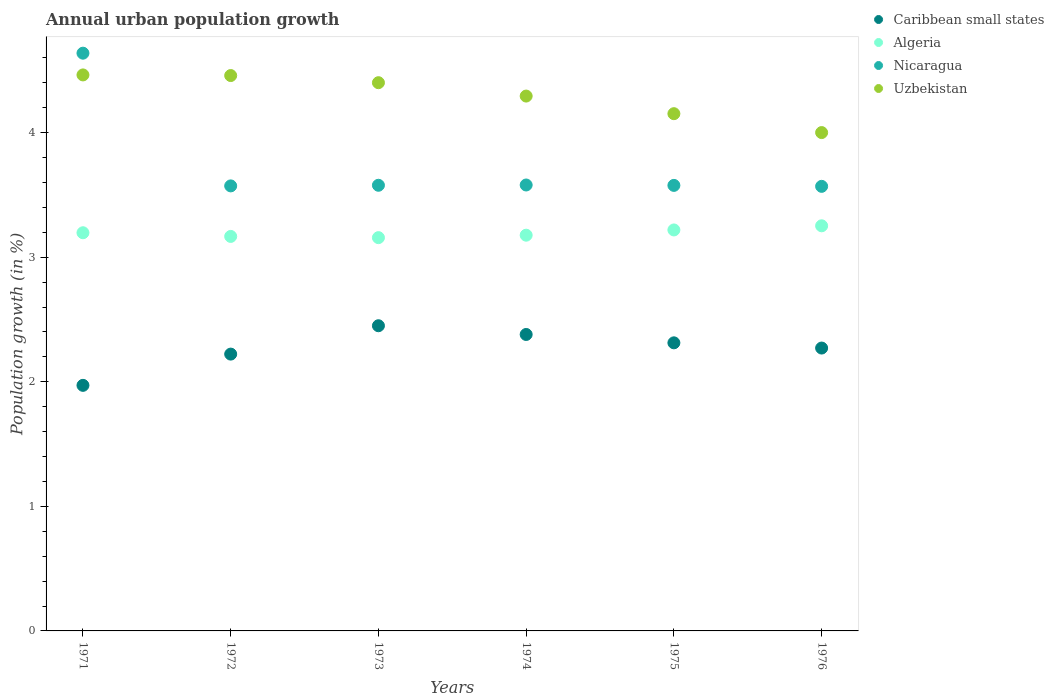How many different coloured dotlines are there?
Provide a short and direct response. 4. What is the percentage of urban population growth in Caribbean small states in 1973?
Offer a very short reply. 2.45. Across all years, what is the maximum percentage of urban population growth in Caribbean small states?
Offer a terse response. 2.45. Across all years, what is the minimum percentage of urban population growth in Caribbean small states?
Your answer should be compact. 1.97. In which year was the percentage of urban population growth in Algeria maximum?
Make the answer very short. 1976. In which year was the percentage of urban population growth in Nicaragua minimum?
Your answer should be compact. 1976. What is the total percentage of urban population growth in Nicaragua in the graph?
Your answer should be very brief. 22.51. What is the difference between the percentage of urban population growth in Nicaragua in 1973 and that in 1976?
Keep it short and to the point. 0.01. What is the difference between the percentage of urban population growth in Nicaragua in 1971 and the percentage of urban population growth in Caribbean small states in 1975?
Keep it short and to the point. 2.33. What is the average percentage of urban population growth in Caribbean small states per year?
Offer a very short reply. 2.27. In the year 1972, what is the difference between the percentage of urban population growth in Uzbekistan and percentage of urban population growth in Nicaragua?
Provide a succinct answer. 0.89. What is the ratio of the percentage of urban population growth in Nicaragua in 1972 to that in 1973?
Offer a very short reply. 1. Is the percentage of urban population growth in Nicaragua in 1972 less than that in 1975?
Give a very brief answer. Yes. Is the difference between the percentage of urban population growth in Uzbekistan in 1973 and 1975 greater than the difference between the percentage of urban population growth in Nicaragua in 1973 and 1975?
Offer a terse response. Yes. What is the difference between the highest and the second highest percentage of urban population growth in Algeria?
Your answer should be very brief. 0.03. What is the difference between the highest and the lowest percentage of urban population growth in Nicaragua?
Your answer should be compact. 1.07. Is it the case that in every year, the sum of the percentage of urban population growth in Nicaragua and percentage of urban population growth in Uzbekistan  is greater than the percentage of urban population growth in Caribbean small states?
Your answer should be compact. Yes. Does the percentage of urban population growth in Caribbean small states monotonically increase over the years?
Offer a very short reply. No. Is the percentage of urban population growth in Algeria strictly greater than the percentage of urban population growth in Uzbekistan over the years?
Your answer should be very brief. No. Is the percentage of urban population growth in Caribbean small states strictly less than the percentage of urban population growth in Nicaragua over the years?
Keep it short and to the point. Yes. How many years are there in the graph?
Offer a terse response. 6. What is the difference between two consecutive major ticks on the Y-axis?
Offer a terse response. 1. Are the values on the major ticks of Y-axis written in scientific E-notation?
Your answer should be compact. No. Does the graph contain any zero values?
Give a very brief answer. No. Does the graph contain grids?
Give a very brief answer. No. Where does the legend appear in the graph?
Your answer should be very brief. Top right. How many legend labels are there?
Keep it short and to the point. 4. What is the title of the graph?
Keep it short and to the point. Annual urban population growth. Does "Nepal" appear as one of the legend labels in the graph?
Your answer should be compact. No. What is the label or title of the X-axis?
Your answer should be very brief. Years. What is the label or title of the Y-axis?
Offer a terse response. Population growth (in %). What is the Population growth (in %) of Caribbean small states in 1971?
Offer a very short reply. 1.97. What is the Population growth (in %) in Algeria in 1971?
Your response must be concise. 3.2. What is the Population growth (in %) in Nicaragua in 1971?
Offer a terse response. 4.64. What is the Population growth (in %) of Uzbekistan in 1971?
Offer a very short reply. 4.46. What is the Population growth (in %) of Caribbean small states in 1972?
Offer a terse response. 2.22. What is the Population growth (in %) of Algeria in 1972?
Your response must be concise. 3.17. What is the Population growth (in %) in Nicaragua in 1972?
Provide a short and direct response. 3.57. What is the Population growth (in %) in Uzbekistan in 1972?
Your response must be concise. 4.46. What is the Population growth (in %) in Caribbean small states in 1973?
Your response must be concise. 2.45. What is the Population growth (in %) in Algeria in 1973?
Give a very brief answer. 3.16. What is the Population growth (in %) in Nicaragua in 1973?
Provide a short and direct response. 3.58. What is the Population growth (in %) in Uzbekistan in 1973?
Provide a succinct answer. 4.4. What is the Population growth (in %) in Caribbean small states in 1974?
Ensure brevity in your answer.  2.38. What is the Population growth (in %) in Algeria in 1974?
Your answer should be compact. 3.18. What is the Population growth (in %) of Nicaragua in 1974?
Ensure brevity in your answer.  3.58. What is the Population growth (in %) of Uzbekistan in 1974?
Provide a short and direct response. 4.29. What is the Population growth (in %) of Caribbean small states in 1975?
Give a very brief answer. 2.31. What is the Population growth (in %) of Algeria in 1975?
Your answer should be compact. 3.22. What is the Population growth (in %) of Nicaragua in 1975?
Give a very brief answer. 3.58. What is the Population growth (in %) in Uzbekistan in 1975?
Provide a short and direct response. 4.15. What is the Population growth (in %) of Caribbean small states in 1976?
Keep it short and to the point. 2.27. What is the Population growth (in %) in Algeria in 1976?
Ensure brevity in your answer.  3.25. What is the Population growth (in %) of Nicaragua in 1976?
Give a very brief answer. 3.57. What is the Population growth (in %) of Uzbekistan in 1976?
Give a very brief answer. 4. Across all years, what is the maximum Population growth (in %) in Caribbean small states?
Your answer should be compact. 2.45. Across all years, what is the maximum Population growth (in %) in Algeria?
Keep it short and to the point. 3.25. Across all years, what is the maximum Population growth (in %) of Nicaragua?
Ensure brevity in your answer.  4.64. Across all years, what is the maximum Population growth (in %) of Uzbekistan?
Ensure brevity in your answer.  4.46. Across all years, what is the minimum Population growth (in %) of Caribbean small states?
Provide a short and direct response. 1.97. Across all years, what is the minimum Population growth (in %) in Algeria?
Give a very brief answer. 3.16. Across all years, what is the minimum Population growth (in %) in Nicaragua?
Offer a terse response. 3.57. Across all years, what is the minimum Population growth (in %) of Uzbekistan?
Provide a short and direct response. 4. What is the total Population growth (in %) in Caribbean small states in the graph?
Offer a very short reply. 13.61. What is the total Population growth (in %) in Algeria in the graph?
Your answer should be very brief. 19.17. What is the total Population growth (in %) of Nicaragua in the graph?
Offer a very short reply. 22.51. What is the total Population growth (in %) in Uzbekistan in the graph?
Give a very brief answer. 25.77. What is the difference between the Population growth (in %) of Caribbean small states in 1971 and that in 1972?
Your answer should be compact. -0.25. What is the difference between the Population growth (in %) of Algeria in 1971 and that in 1972?
Provide a succinct answer. 0.03. What is the difference between the Population growth (in %) of Nicaragua in 1971 and that in 1972?
Your response must be concise. 1.07. What is the difference between the Population growth (in %) in Uzbekistan in 1971 and that in 1972?
Your answer should be very brief. 0.01. What is the difference between the Population growth (in %) of Caribbean small states in 1971 and that in 1973?
Ensure brevity in your answer.  -0.48. What is the difference between the Population growth (in %) in Algeria in 1971 and that in 1973?
Ensure brevity in your answer.  0.04. What is the difference between the Population growth (in %) of Nicaragua in 1971 and that in 1973?
Provide a succinct answer. 1.06. What is the difference between the Population growth (in %) in Uzbekistan in 1971 and that in 1973?
Offer a very short reply. 0.06. What is the difference between the Population growth (in %) in Caribbean small states in 1971 and that in 1974?
Offer a terse response. -0.41. What is the difference between the Population growth (in %) in Algeria in 1971 and that in 1974?
Make the answer very short. 0.02. What is the difference between the Population growth (in %) of Nicaragua in 1971 and that in 1974?
Keep it short and to the point. 1.06. What is the difference between the Population growth (in %) of Uzbekistan in 1971 and that in 1974?
Your answer should be compact. 0.17. What is the difference between the Population growth (in %) of Caribbean small states in 1971 and that in 1975?
Your answer should be very brief. -0.34. What is the difference between the Population growth (in %) of Algeria in 1971 and that in 1975?
Offer a terse response. -0.02. What is the difference between the Population growth (in %) of Nicaragua in 1971 and that in 1975?
Your answer should be compact. 1.06. What is the difference between the Population growth (in %) of Uzbekistan in 1971 and that in 1975?
Your answer should be compact. 0.31. What is the difference between the Population growth (in %) of Caribbean small states in 1971 and that in 1976?
Your response must be concise. -0.3. What is the difference between the Population growth (in %) of Algeria in 1971 and that in 1976?
Make the answer very short. -0.06. What is the difference between the Population growth (in %) of Nicaragua in 1971 and that in 1976?
Your answer should be compact. 1.07. What is the difference between the Population growth (in %) of Uzbekistan in 1971 and that in 1976?
Give a very brief answer. 0.46. What is the difference between the Population growth (in %) in Caribbean small states in 1972 and that in 1973?
Make the answer very short. -0.23. What is the difference between the Population growth (in %) in Algeria in 1972 and that in 1973?
Ensure brevity in your answer.  0.01. What is the difference between the Population growth (in %) of Nicaragua in 1972 and that in 1973?
Make the answer very short. -0.01. What is the difference between the Population growth (in %) of Uzbekistan in 1972 and that in 1973?
Provide a succinct answer. 0.06. What is the difference between the Population growth (in %) in Caribbean small states in 1972 and that in 1974?
Your answer should be compact. -0.16. What is the difference between the Population growth (in %) of Algeria in 1972 and that in 1974?
Your response must be concise. -0.01. What is the difference between the Population growth (in %) in Nicaragua in 1972 and that in 1974?
Offer a very short reply. -0.01. What is the difference between the Population growth (in %) of Uzbekistan in 1972 and that in 1974?
Provide a succinct answer. 0.16. What is the difference between the Population growth (in %) in Caribbean small states in 1972 and that in 1975?
Your answer should be compact. -0.09. What is the difference between the Population growth (in %) of Algeria in 1972 and that in 1975?
Make the answer very short. -0.05. What is the difference between the Population growth (in %) of Nicaragua in 1972 and that in 1975?
Your answer should be very brief. -0. What is the difference between the Population growth (in %) of Uzbekistan in 1972 and that in 1975?
Provide a short and direct response. 0.31. What is the difference between the Population growth (in %) in Caribbean small states in 1972 and that in 1976?
Give a very brief answer. -0.05. What is the difference between the Population growth (in %) in Algeria in 1972 and that in 1976?
Your answer should be compact. -0.09. What is the difference between the Population growth (in %) of Nicaragua in 1972 and that in 1976?
Keep it short and to the point. 0. What is the difference between the Population growth (in %) of Uzbekistan in 1972 and that in 1976?
Offer a very short reply. 0.46. What is the difference between the Population growth (in %) in Caribbean small states in 1973 and that in 1974?
Give a very brief answer. 0.07. What is the difference between the Population growth (in %) of Algeria in 1973 and that in 1974?
Provide a short and direct response. -0.02. What is the difference between the Population growth (in %) in Nicaragua in 1973 and that in 1974?
Ensure brevity in your answer.  -0. What is the difference between the Population growth (in %) in Uzbekistan in 1973 and that in 1974?
Your answer should be very brief. 0.11. What is the difference between the Population growth (in %) of Caribbean small states in 1973 and that in 1975?
Keep it short and to the point. 0.14. What is the difference between the Population growth (in %) in Algeria in 1973 and that in 1975?
Make the answer very short. -0.06. What is the difference between the Population growth (in %) of Uzbekistan in 1973 and that in 1975?
Ensure brevity in your answer.  0.25. What is the difference between the Population growth (in %) in Caribbean small states in 1973 and that in 1976?
Your answer should be very brief. 0.18. What is the difference between the Population growth (in %) in Algeria in 1973 and that in 1976?
Provide a short and direct response. -0.1. What is the difference between the Population growth (in %) of Nicaragua in 1973 and that in 1976?
Provide a succinct answer. 0.01. What is the difference between the Population growth (in %) in Uzbekistan in 1973 and that in 1976?
Ensure brevity in your answer.  0.4. What is the difference between the Population growth (in %) of Caribbean small states in 1974 and that in 1975?
Offer a terse response. 0.07. What is the difference between the Population growth (in %) in Algeria in 1974 and that in 1975?
Ensure brevity in your answer.  -0.04. What is the difference between the Population growth (in %) of Nicaragua in 1974 and that in 1975?
Your answer should be compact. 0. What is the difference between the Population growth (in %) in Uzbekistan in 1974 and that in 1975?
Make the answer very short. 0.14. What is the difference between the Population growth (in %) of Caribbean small states in 1974 and that in 1976?
Your response must be concise. 0.11. What is the difference between the Population growth (in %) of Algeria in 1974 and that in 1976?
Give a very brief answer. -0.08. What is the difference between the Population growth (in %) of Nicaragua in 1974 and that in 1976?
Your answer should be very brief. 0.01. What is the difference between the Population growth (in %) of Uzbekistan in 1974 and that in 1976?
Your answer should be compact. 0.29. What is the difference between the Population growth (in %) of Caribbean small states in 1975 and that in 1976?
Offer a very short reply. 0.04. What is the difference between the Population growth (in %) in Algeria in 1975 and that in 1976?
Ensure brevity in your answer.  -0.03. What is the difference between the Population growth (in %) of Nicaragua in 1975 and that in 1976?
Keep it short and to the point. 0.01. What is the difference between the Population growth (in %) of Uzbekistan in 1975 and that in 1976?
Keep it short and to the point. 0.15. What is the difference between the Population growth (in %) of Caribbean small states in 1971 and the Population growth (in %) of Algeria in 1972?
Provide a short and direct response. -1.2. What is the difference between the Population growth (in %) of Caribbean small states in 1971 and the Population growth (in %) of Nicaragua in 1972?
Make the answer very short. -1.6. What is the difference between the Population growth (in %) in Caribbean small states in 1971 and the Population growth (in %) in Uzbekistan in 1972?
Your answer should be compact. -2.49. What is the difference between the Population growth (in %) of Algeria in 1971 and the Population growth (in %) of Nicaragua in 1972?
Your answer should be very brief. -0.38. What is the difference between the Population growth (in %) of Algeria in 1971 and the Population growth (in %) of Uzbekistan in 1972?
Your answer should be very brief. -1.26. What is the difference between the Population growth (in %) in Nicaragua in 1971 and the Population growth (in %) in Uzbekistan in 1972?
Make the answer very short. 0.18. What is the difference between the Population growth (in %) of Caribbean small states in 1971 and the Population growth (in %) of Algeria in 1973?
Provide a succinct answer. -1.19. What is the difference between the Population growth (in %) in Caribbean small states in 1971 and the Population growth (in %) in Nicaragua in 1973?
Your answer should be very brief. -1.61. What is the difference between the Population growth (in %) in Caribbean small states in 1971 and the Population growth (in %) in Uzbekistan in 1973?
Keep it short and to the point. -2.43. What is the difference between the Population growth (in %) of Algeria in 1971 and the Population growth (in %) of Nicaragua in 1973?
Ensure brevity in your answer.  -0.38. What is the difference between the Population growth (in %) of Algeria in 1971 and the Population growth (in %) of Uzbekistan in 1973?
Give a very brief answer. -1.2. What is the difference between the Population growth (in %) in Nicaragua in 1971 and the Population growth (in %) in Uzbekistan in 1973?
Make the answer very short. 0.24. What is the difference between the Population growth (in %) of Caribbean small states in 1971 and the Population growth (in %) of Algeria in 1974?
Your answer should be compact. -1.21. What is the difference between the Population growth (in %) in Caribbean small states in 1971 and the Population growth (in %) in Nicaragua in 1974?
Your answer should be compact. -1.61. What is the difference between the Population growth (in %) in Caribbean small states in 1971 and the Population growth (in %) in Uzbekistan in 1974?
Provide a succinct answer. -2.32. What is the difference between the Population growth (in %) in Algeria in 1971 and the Population growth (in %) in Nicaragua in 1974?
Make the answer very short. -0.38. What is the difference between the Population growth (in %) in Algeria in 1971 and the Population growth (in %) in Uzbekistan in 1974?
Make the answer very short. -1.1. What is the difference between the Population growth (in %) of Nicaragua in 1971 and the Population growth (in %) of Uzbekistan in 1974?
Offer a very short reply. 0.34. What is the difference between the Population growth (in %) in Caribbean small states in 1971 and the Population growth (in %) in Algeria in 1975?
Make the answer very short. -1.25. What is the difference between the Population growth (in %) of Caribbean small states in 1971 and the Population growth (in %) of Nicaragua in 1975?
Give a very brief answer. -1.61. What is the difference between the Population growth (in %) in Caribbean small states in 1971 and the Population growth (in %) in Uzbekistan in 1975?
Your response must be concise. -2.18. What is the difference between the Population growth (in %) of Algeria in 1971 and the Population growth (in %) of Nicaragua in 1975?
Your response must be concise. -0.38. What is the difference between the Population growth (in %) of Algeria in 1971 and the Population growth (in %) of Uzbekistan in 1975?
Offer a very short reply. -0.96. What is the difference between the Population growth (in %) in Nicaragua in 1971 and the Population growth (in %) in Uzbekistan in 1975?
Your answer should be compact. 0.49. What is the difference between the Population growth (in %) in Caribbean small states in 1971 and the Population growth (in %) in Algeria in 1976?
Provide a short and direct response. -1.28. What is the difference between the Population growth (in %) in Caribbean small states in 1971 and the Population growth (in %) in Nicaragua in 1976?
Provide a short and direct response. -1.6. What is the difference between the Population growth (in %) of Caribbean small states in 1971 and the Population growth (in %) of Uzbekistan in 1976?
Ensure brevity in your answer.  -2.03. What is the difference between the Population growth (in %) of Algeria in 1971 and the Population growth (in %) of Nicaragua in 1976?
Offer a terse response. -0.37. What is the difference between the Population growth (in %) of Algeria in 1971 and the Population growth (in %) of Uzbekistan in 1976?
Make the answer very short. -0.8. What is the difference between the Population growth (in %) in Nicaragua in 1971 and the Population growth (in %) in Uzbekistan in 1976?
Make the answer very short. 0.64. What is the difference between the Population growth (in %) in Caribbean small states in 1972 and the Population growth (in %) in Algeria in 1973?
Offer a terse response. -0.93. What is the difference between the Population growth (in %) in Caribbean small states in 1972 and the Population growth (in %) in Nicaragua in 1973?
Your answer should be very brief. -1.36. What is the difference between the Population growth (in %) of Caribbean small states in 1972 and the Population growth (in %) of Uzbekistan in 1973?
Provide a short and direct response. -2.18. What is the difference between the Population growth (in %) in Algeria in 1972 and the Population growth (in %) in Nicaragua in 1973?
Offer a terse response. -0.41. What is the difference between the Population growth (in %) in Algeria in 1972 and the Population growth (in %) in Uzbekistan in 1973?
Provide a short and direct response. -1.23. What is the difference between the Population growth (in %) of Nicaragua in 1972 and the Population growth (in %) of Uzbekistan in 1973?
Your answer should be very brief. -0.83. What is the difference between the Population growth (in %) of Caribbean small states in 1972 and the Population growth (in %) of Algeria in 1974?
Give a very brief answer. -0.95. What is the difference between the Population growth (in %) of Caribbean small states in 1972 and the Population growth (in %) of Nicaragua in 1974?
Provide a succinct answer. -1.36. What is the difference between the Population growth (in %) in Caribbean small states in 1972 and the Population growth (in %) in Uzbekistan in 1974?
Ensure brevity in your answer.  -2.07. What is the difference between the Population growth (in %) in Algeria in 1972 and the Population growth (in %) in Nicaragua in 1974?
Provide a short and direct response. -0.41. What is the difference between the Population growth (in %) in Algeria in 1972 and the Population growth (in %) in Uzbekistan in 1974?
Keep it short and to the point. -1.13. What is the difference between the Population growth (in %) of Nicaragua in 1972 and the Population growth (in %) of Uzbekistan in 1974?
Provide a succinct answer. -0.72. What is the difference between the Population growth (in %) in Caribbean small states in 1972 and the Population growth (in %) in Algeria in 1975?
Provide a short and direct response. -1. What is the difference between the Population growth (in %) in Caribbean small states in 1972 and the Population growth (in %) in Nicaragua in 1975?
Provide a short and direct response. -1.35. What is the difference between the Population growth (in %) in Caribbean small states in 1972 and the Population growth (in %) in Uzbekistan in 1975?
Provide a succinct answer. -1.93. What is the difference between the Population growth (in %) in Algeria in 1972 and the Population growth (in %) in Nicaragua in 1975?
Offer a very short reply. -0.41. What is the difference between the Population growth (in %) in Algeria in 1972 and the Population growth (in %) in Uzbekistan in 1975?
Give a very brief answer. -0.99. What is the difference between the Population growth (in %) of Nicaragua in 1972 and the Population growth (in %) of Uzbekistan in 1975?
Provide a succinct answer. -0.58. What is the difference between the Population growth (in %) of Caribbean small states in 1972 and the Population growth (in %) of Algeria in 1976?
Offer a terse response. -1.03. What is the difference between the Population growth (in %) of Caribbean small states in 1972 and the Population growth (in %) of Nicaragua in 1976?
Your answer should be very brief. -1.35. What is the difference between the Population growth (in %) of Caribbean small states in 1972 and the Population growth (in %) of Uzbekistan in 1976?
Your answer should be compact. -1.78. What is the difference between the Population growth (in %) in Algeria in 1972 and the Population growth (in %) in Nicaragua in 1976?
Your answer should be compact. -0.4. What is the difference between the Population growth (in %) of Algeria in 1972 and the Population growth (in %) of Uzbekistan in 1976?
Provide a succinct answer. -0.83. What is the difference between the Population growth (in %) in Nicaragua in 1972 and the Population growth (in %) in Uzbekistan in 1976?
Your response must be concise. -0.43. What is the difference between the Population growth (in %) in Caribbean small states in 1973 and the Population growth (in %) in Algeria in 1974?
Your answer should be compact. -0.73. What is the difference between the Population growth (in %) in Caribbean small states in 1973 and the Population growth (in %) in Nicaragua in 1974?
Offer a very short reply. -1.13. What is the difference between the Population growth (in %) in Caribbean small states in 1973 and the Population growth (in %) in Uzbekistan in 1974?
Offer a very short reply. -1.84. What is the difference between the Population growth (in %) in Algeria in 1973 and the Population growth (in %) in Nicaragua in 1974?
Give a very brief answer. -0.42. What is the difference between the Population growth (in %) of Algeria in 1973 and the Population growth (in %) of Uzbekistan in 1974?
Ensure brevity in your answer.  -1.14. What is the difference between the Population growth (in %) in Nicaragua in 1973 and the Population growth (in %) in Uzbekistan in 1974?
Offer a terse response. -0.72. What is the difference between the Population growth (in %) of Caribbean small states in 1973 and the Population growth (in %) of Algeria in 1975?
Make the answer very short. -0.77. What is the difference between the Population growth (in %) in Caribbean small states in 1973 and the Population growth (in %) in Nicaragua in 1975?
Provide a short and direct response. -1.13. What is the difference between the Population growth (in %) in Caribbean small states in 1973 and the Population growth (in %) in Uzbekistan in 1975?
Offer a terse response. -1.7. What is the difference between the Population growth (in %) in Algeria in 1973 and the Population growth (in %) in Nicaragua in 1975?
Provide a short and direct response. -0.42. What is the difference between the Population growth (in %) in Algeria in 1973 and the Population growth (in %) in Uzbekistan in 1975?
Your answer should be compact. -1. What is the difference between the Population growth (in %) in Nicaragua in 1973 and the Population growth (in %) in Uzbekistan in 1975?
Offer a very short reply. -0.57. What is the difference between the Population growth (in %) in Caribbean small states in 1973 and the Population growth (in %) in Algeria in 1976?
Your response must be concise. -0.8. What is the difference between the Population growth (in %) of Caribbean small states in 1973 and the Population growth (in %) of Nicaragua in 1976?
Ensure brevity in your answer.  -1.12. What is the difference between the Population growth (in %) in Caribbean small states in 1973 and the Population growth (in %) in Uzbekistan in 1976?
Make the answer very short. -1.55. What is the difference between the Population growth (in %) in Algeria in 1973 and the Population growth (in %) in Nicaragua in 1976?
Make the answer very short. -0.41. What is the difference between the Population growth (in %) in Algeria in 1973 and the Population growth (in %) in Uzbekistan in 1976?
Make the answer very short. -0.84. What is the difference between the Population growth (in %) in Nicaragua in 1973 and the Population growth (in %) in Uzbekistan in 1976?
Provide a short and direct response. -0.42. What is the difference between the Population growth (in %) in Caribbean small states in 1974 and the Population growth (in %) in Algeria in 1975?
Offer a very short reply. -0.84. What is the difference between the Population growth (in %) of Caribbean small states in 1974 and the Population growth (in %) of Nicaragua in 1975?
Provide a succinct answer. -1.2. What is the difference between the Population growth (in %) of Caribbean small states in 1974 and the Population growth (in %) of Uzbekistan in 1975?
Give a very brief answer. -1.77. What is the difference between the Population growth (in %) in Algeria in 1974 and the Population growth (in %) in Nicaragua in 1975?
Offer a terse response. -0.4. What is the difference between the Population growth (in %) of Algeria in 1974 and the Population growth (in %) of Uzbekistan in 1975?
Ensure brevity in your answer.  -0.98. What is the difference between the Population growth (in %) of Nicaragua in 1974 and the Population growth (in %) of Uzbekistan in 1975?
Offer a very short reply. -0.57. What is the difference between the Population growth (in %) in Caribbean small states in 1974 and the Population growth (in %) in Algeria in 1976?
Offer a terse response. -0.87. What is the difference between the Population growth (in %) in Caribbean small states in 1974 and the Population growth (in %) in Nicaragua in 1976?
Your answer should be compact. -1.19. What is the difference between the Population growth (in %) of Caribbean small states in 1974 and the Population growth (in %) of Uzbekistan in 1976?
Your response must be concise. -1.62. What is the difference between the Population growth (in %) in Algeria in 1974 and the Population growth (in %) in Nicaragua in 1976?
Give a very brief answer. -0.39. What is the difference between the Population growth (in %) in Algeria in 1974 and the Population growth (in %) in Uzbekistan in 1976?
Give a very brief answer. -0.82. What is the difference between the Population growth (in %) of Nicaragua in 1974 and the Population growth (in %) of Uzbekistan in 1976?
Your response must be concise. -0.42. What is the difference between the Population growth (in %) of Caribbean small states in 1975 and the Population growth (in %) of Algeria in 1976?
Provide a short and direct response. -0.94. What is the difference between the Population growth (in %) of Caribbean small states in 1975 and the Population growth (in %) of Nicaragua in 1976?
Make the answer very short. -1.26. What is the difference between the Population growth (in %) in Caribbean small states in 1975 and the Population growth (in %) in Uzbekistan in 1976?
Give a very brief answer. -1.69. What is the difference between the Population growth (in %) in Algeria in 1975 and the Population growth (in %) in Nicaragua in 1976?
Keep it short and to the point. -0.35. What is the difference between the Population growth (in %) in Algeria in 1975 and the Population growth (in %) in Uzbekistan in 1976?
Your answer should be compact. -0.78. What is the difference between the Population growth (in %) of Nicaragua in 1975 and the Population growth (in %) of Uzbekistan in 1976?
Provide a short and direct response. -0.42. What is the average Population growth (in %) in Caribbean small states per year?
Give a very brief answer. 2.27. What is the average Population growth (in %) of Algeria per year?
Provide a succinct answer. 3.19. What is the average Population growth (in %) in Nicaragua per year?
Offer a very short reply. 3.75. What is the average Population growth (in %) in Uzbekistan per year?
Give a very brief answer. 4.29. In the year 1971, what is the difference between the Population growth (in %) of Caribbean small states and Population growth (in %) of Algeria?
Provide a succinct answer. -1.23. In the year 1971, what is the difference between the Population growth (in %) in Caribbean small states and Population growth (in %) in Nicaragua?
Your answer should be very brief. -2.67. In the year 1971, what is the difference between the Population growth (in %) in Caribbean small states and Population growth (in %) in Uzbekistan?
Offer a very short reply. -2.49. In the year 1971, what is the difference between the Population growth (in %) in Algeria and Population growth (in %) in Nicaragua?
Offer a terse response. -1.44. In the year 1971, what is the difference between the Population growth (in %) of Algeria and Population growth (in %) of Uzbekistan?
Your answer should be compact. -1.27. In the year 1971, what is the difference between the Population growth (in %) in Nicaragua and Population growth (in %) in Uzbekistan?
Your answer should be very brief. 0.17. In the year 1972, what is the difference between the Population growth (in %) of Caribbean small states and Population growth (in %) of Algeria?
Ensure brevity in your answer.  -0.94. In the year 1972, what is the difference between the Population growth (in %) in Caribbean small states and Population growth (in %) in Nicaragua?
Offer a terse response. -1.35. In the year 1972, what is the difference between the Population growth (in %) of Caribbean small states and Population growth (in %) of Uzbekistan?
Offer a very short reply. -2.24. In the year 1972, what is the difference between the Population growth (in %) of Algeria and Population growth (in %) of Nicaragua?
Offer a very short reply. -0.41. In the year 1972, what is the difference between the Population growth (in %) of Algeria and Population growth (in %) of Uzbekistan?
Give a very brief answer. -1.29. In the year 1972, what is the difference between the Population growth (in %) of Nicaragua and Population growth (in %) of Uzbekistan?
Offer a terse response. -0.89. In the year 1973, what is the difference between the Population growth (in %) in Caribbean small states and Population growth (in %) in Algeria?
Offer a terse response. -0.71. In the year 1973, what is the difference between the Population growth (in %) in Caribbean small states and Population growth (in %) in Nicaragua?
Your response must be concise. -1.13. In the year 1973, what is the difference between the Population growth (in %) in Caribbean small states and Population growth (in %) in Uzbekistan?
Make the answer very short. -1.95. In the year 1973, what is the difference between the Population growth (in %) in Algeria and Population growth (in %) in Nicaragua?
Ensure brevity in your answer.  -0.42. In the year 1973, what is the difference between the Population growth (in %) in Algeria and Population growth (in %) in Uzbekistan?
Provide a short and direct response. -1.24. In the year 1973, what is the difference between the Population growth (in %) in Nicaragua and Population growth (in %) in Uzbekistan?
Provide a short and direct response. -0.82. In the year 1974, what is the difference between the Population growth (in %) of Caribbean small states and Population growth (in %) of Algeria?
Offer a terse response. -0.8. In the year 1974, what is the difference between the Population growth (in %) in Caribbean small states and Population growth (in %) in Nicaragua?
Give a very brief answer. -1.2. In the year 1974, what is the difference between the Population growth (in %) in Caribbean small states and Population growth (in %) in Uzbekistan?
Your answer should be compact. -1.91. In the year 1974, what is the difference between the Population growth (in %) of Algeria and Population growth (in %) of Nicaragua?
Offer a very short reply. -0.4. In the year 1974, what is the difference between the Population growth (in %) of Algeria and Population growth (in %) of Uzbekistan?
Your answer should be very brief. -1.12. In the year 1974, what is the difference between the Population growth (in %) of Nicaragua and Population growth (in %) of Uzbekistan?
Your answer should be compact. -0.71. In the year 1975, what is the difference between the Population growth (in %) in Caribbean small states and Population growth (in %) in Algeria?
Keep it short and to the point. -0.91. In the year 1975, what is the difference between the Population growth (in %) in Caribbean small states and Population growth (in %) in Nicaragua?
Your response must be concise. -1.26. In the year 1975, what is the difference between the Population growth (in %) in Caribbean small states and Population growth (in %) in Uzbekistan?
Offer a terse response. -1.84. In the year 1975, what is the difference between the Population growth (in %) in Algeria and Population growth (in %) in Nicaragua?
Give a very brief answer. -0.36. In the year 1975, what is the difference between the Population growth (in %) of Algeria and Population growth (in %) of Uzbekistan?
Provide a succinct answer. -0.93. In the year 1975, what is the difference between the Population growth (in %) of Nicaragua and Population growth (in %) of Uzbekistan?
Give a very brief answer. -0.58. In the year 1976, what is the difference between the Population growth (in %) of Caribbean small states and Population growth (in %) of Algeria?
Give a very brief answer. -0.98. In the year 1976, what is the difference between the Population growth (in %) of Caribbean small states and Population growth (in %) of Nicaragua?
Offer a very short reply. -1.3. In the year 1976, what is the difference between the Population growth (in %) in Caribbean small states and Population growth (in %) in Uzbekistan?
Your answer should be compact. -1.73. In the year 1976, what is the difference between the Population growth (in %) of Algeria and Population growth (in %) of Nicaragua?
Keep it short and to the point. -0.32. In the year 1976, what is the difference between the Population growth (in %) in Algeria and Population growth (in %) in Uzbekistan?
Offer a terse response. -0.75. In the year 1976, what is the difference between the Population growth (in %) in Nicaragua and Population growth (in %) in Uzbekistan?
Provide a short and direct response. -0.43. What is the ratio of the Population growth (in %) in Caribbean small states in 1971 to that in 1972?
Provide a short and direct response. 0.89. What is the ratio of the Population growth (in %) in Algeria in 1971 to that in 1972?
Provide a short and direct response. 1.01. What is the ratio of the Population growth (in %) in Nicaragua in 1971 to that in 1972?
Offer a terse response. 1.3. What is the ratio of the Population growth (in %) in Caribbean small states in 1971 to that in 1973?
Your answer should be very brief. 0.8. What is the ratio of the Population growth (in %) of Algeria in 1971 to that in 1973?
Make the answer very short. 1.01. What is the ratio of the Population growth (in %) in Nicaragua in 1971 to that in 1973?
Provide a short and direct response. 1.3. What is the ratio of the Population growth (in %) of Uzbekistan in 1971 to that in 1973?
Your answer should be compact. 1.01. What is the ratio of the Population growth (in %) of Caribbean small states in 1971 to that in 1974?
Provide a succinct answer. 0.83. What is the ratio of the Population growth (in %) of Algeria in 1971 to that in 1974?
Offer a very short reply. 1.01. What is the ratio of the Population growth (in %) of Nicaragua in 1971 to that in 1974?
Your answer should be very brief. 1.3. What is the ratio of the Population growth (in %) in Uzbekistan in 1971 to that in 1974?
Keep it short and to the point. 1.04. What is the ratio of the Population growth (in %) in Caribbean small states in 1971 to that in 1975?
Your answer should be compact. 0.85. What is the ratio of the Population growth (in %) of Nicaragua in 1971 to that in 1975?
Keep it short and to the point. 1.3. What is the ratio of the Population growth (in %) in Uzbekistan in 1971 to that in 1975?
Ensure brevity in your answer.  1.07. What is the ratio of the Population growth (in %) of Caribbean small states in 1971 to that in 1976?
Provide a short and direct response. 0.87. What is the ratio of the Population growth (in %) in Algeria in 1971 to that in 1976?
Offer a terse response. 0.98. What is the ratio of the Population growth (in %) of Nicaragua in 1971 to that in 1976?
Provide a short and direct response. 1.3. What is the ratio of the Population growth (in %) in Uzbekistan in 1971 to that in 1976?
Give a very brief answer. 1.12. What is the ratio of the Population growth (in %) in Caribbean small states in 1972 to that in 1973?
Your answer should be compact. 0.91. What is the ratio of the Population growth (in %) of Algeria in 1972 to that in 1973?
Offer a terse response. 1. What is the ratio of the Population growth (in %) of Nicaragua in 1972 to that in 1973?
Provide a short and direct response. 1. What is the ratio of the Population growth (in %) of Uzbekistan in 1972 to that in 1973?
Your answer should be very brief. 1.01. What is the ratio of the Population growth (in %) in Caribbean small states in 1972 to that in 1974?
Offer a terse response. 0.93. What is the ratio of the Population growth (in %) of Algeria in 1972 to that in 1974?
Provide a succinct answer. 1. What is the ratio of the Population growth (in %) in Nicaragua in 1972 to that in 1974?
Keep it short and to the point. 1. What is the ratio of the Population growth (in %) in Uzbekistan in 1972 to that in 1974?
Your response must be concise. 1.04. What is the ratio of the Population growth (in %) in Caribbean small states in 1972 to that in 1975?
Offer a terse response. 0.96. What is the ratio of the Population growth (in %) of Algeria in 1972 to that in 1975?
Keep it short and to the point. 0.98. What is the ratio of the Population growth (in %) in Nicaragua in 1972 to that in 1975?
Ensure brevity in your answer.  1. What is the ratio of the Population growth (in %) in Uzbekistan in 1972 to that in 1975?
Ensure brevity in your answer.  1.07. What is the ratio of the Population growth (in %) in Caribbean small states in 1972 to that in 1976?
Offer a very short reply. 0.98. What is the ratio of the Population growth (in %) of Algeria in 1972 to that in 1976?
Make the answer very short. 0.97. What is the ratio of the Population growth (in %) of Uzbekistan in 1972 to that in 1976?
Offer a very short reply. 1.11. What is the ratio of the Population growth (in %) in Caribbean small states in 1973 to that in 1974?
Ensure brevity in your answer.  1.03. What is the ratio of the Population growth (in %) in Uzbekistan in 1973 to that in 1974?
Keep it short and to the point. 1.02. What is the ratio of the Population growth (in %) of Caribbean small states in 1973 to that in 1975?
Offer a terse response. 1.06. What is the ratio of the Population growth (in %) in Algeria in 1973 to that in 1975?
Offer a very short reply. 0.98. What is the ratio of the Population growth (in %) in Nicaragua in 1973 to that in 1975?
Give a very brief answer. 1. What is the ratio of the Population growth (in %) of Uzbekistan in 1973 to that in 1975?
Give a very brief answer. 1.06. What is the ratio of the Population growth (in %) in Caribbean small states in 1973 to that in 1976?
Keep it short and to the point. 1.08. What is the ratio of the Population growth (in %) in Algeria in 1973 to that in 1976?
Ensure brevity in your answer.  0.97. What is the ratio of the Population growth (in %) in Nicaragua in 1973 to that in 1976?
Make the answer very short. 1. What is the ratio of the Population growth (in %) in Uzbekistan in 1973 to that in 1976?
Ensure brevity in your answer.  1.1. What is the ratio of the Population growth (in %) of Caribbean small states in 1974 to that in 1975?
Your response must be concise. 1.03. What is the ratio of the Population growth (in %) of Algeria in 1974 to that in 1975?
Ensure brevity in your answer.  0.99. What is the ratio of the Population growth (in %) of Nicaragua in 1974 to that in 1975?
Your answer should be very brief. 1. What is the ratio of the Population growth (in %) of Uzbekistan in 1974 to that in 1975?
Provide a succinct answer. 1.03. What is the ratio of the Population growth (in %) of Caribbean small states in 1974 to that in 1976?
Your response must be concise. 1.05. What is the ratio of the Population growth (in %) in Algeria in 1974 to that in 1976?
Keep it short and to the point. 0.98. What is the ratio of the Population growth (in %) in Uzbekistan in 1974 to that in 1976?
Keep it short and to the point. 1.07. What is the ratio of the Population growth (in %) of Caribbean small states in 1975 to that in 1976?
Your response must be concise. 1.02. What is the ratio of the Population growth (in %) of Nicaragua in 1975 to that in 1976?
Provide a short and direct response. 1. What is the ratio of the Population growth (in %) in Uzbekistan in 1975 to that in 1976?
Ensure brevity in your answer.  1.04. What is the difference between the highest and the second highest Population growth (in %) in Caribbean small states?
Give a very brief answer. 0.07. What is the difference between the highest and the second highest Population growth (in %) of Nicaragua?
Provide a succinct answer. 1.06. What is the difference between the highest and the second highest Population growth (in %) in Uzbekistan?
Provide a short and direct response. 0.01. What is the difference between the highest and the lowest Population growth (in %) of Caribbean small states?
Keep it short and to the point. 0.48. What is the difference between the highest and the lowest Population growth (in %) in Algeria?
Make the answer very short. 0.1. What is the difference between the highest and the lowest Population growth (in %) in Nicaragua?
Your answer should be compact. 1.07. What is the difference between the highest and the lowest Population growth (in %) of Uzbekistan?
Give a very brief answer. 0.46. 